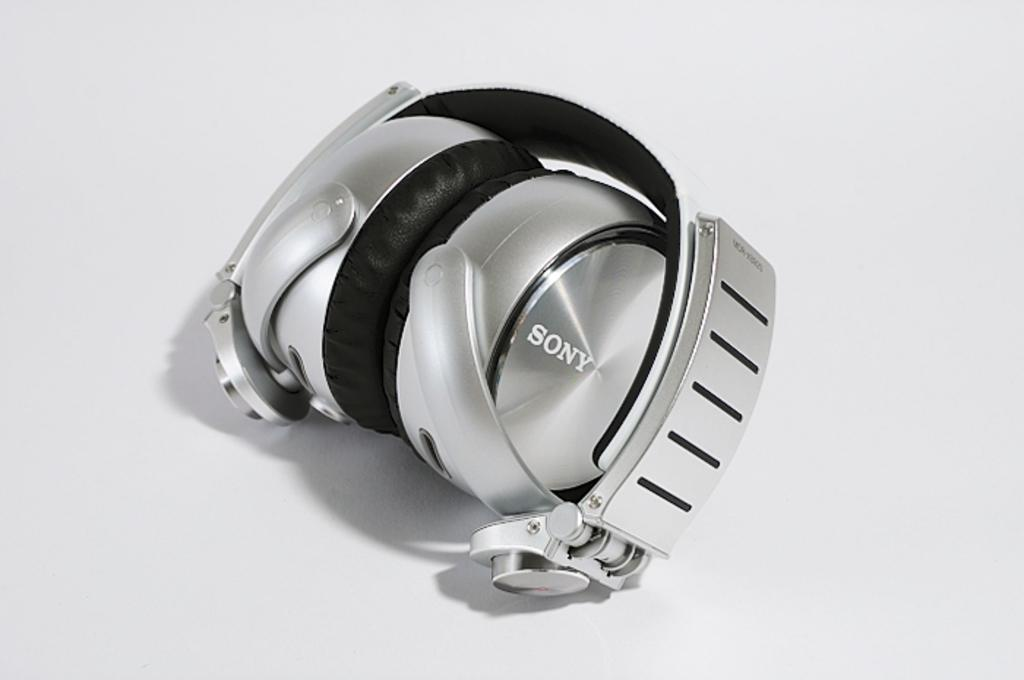<image>
Relay a brief, clear account of the picture shown. A pair of sony headphone sits alone on a white background. 